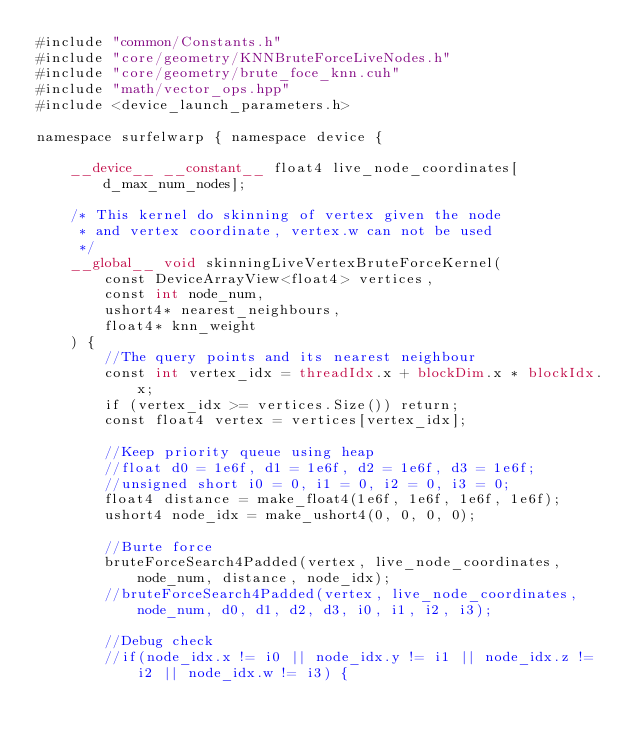Convert code to text. <code><loc_0><loc_0><loc_500><loc_500><_Cuda_>#include "common/Constants.h"
#include "core/geometry/KNNBruteForceLiveNodes.h"
#include "core/geometry/brute_foce_knn.cuh"
#include "math/vector_ops.hpp"
#include <device_launch_parameters.h>

namespace surfelwarp { namespace device {
		
	__device__ __constant__ float4 live_node_coordinates[d_max_num_nodes];
	
	/* This kernel do skinning of vertex given the node
	 * and vertex coordinate, vertex.w can not be used
	 */
	__global__ void skinningLiveVertexBruteForceKernel(
		const DeviceArrayView<float4> vertices,
		const int node_num,
		ushort4* nearest_neighbours,
		float4* knn_weight
	) {
		//The query points and its nearest neighbour
		const int vertex_idx = threadIdx.x + blockDim.x * blockIdx.x;
		if (vertex_idx >= vertices.Size()) return;
		const float4 vertex = vertices[vertex_idx];

		//Keep priority queue using heap
		//float d0 = 1e6f, d1 = 1e6f, d2 = 1e6f, d3 = 1e6f;
		//unsigned short i0 = 0, i1 = 0, i2 = 0, i3 = 0;
		float4 distance = make_float4(1e6f, 1e6f, 1e6f, 1e6f);
		ushort4 node_idx = make_ushort4(0, 0, 0, 0);

		//Burte force
		bruteForceSearch4Padded(vertex, live_node_coordinates, node_num, distance, node_idx);
		//bruteForceSearch4Padded(vertex, live_node_coordinates, node_num, d0, d1, d2, d3, i0, i1, i2, i3);

		//Debug check
		//if(node_idx.x != i0 || node_idx.y != i1 || node_idx.z != i2 || node_idx.w != i3) {</code> 